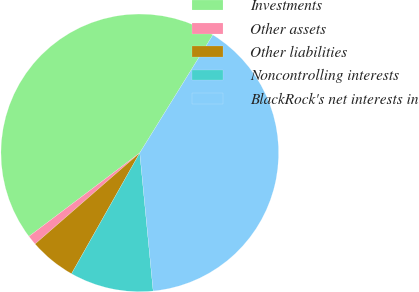<chart> <loc_0><loc_0><loc_500><loc_500><pie_chart><fcel>Investments<fcel>Other assets<fcel>Other liabilities<fcel>Noncontrolling interests<fcel>BlackRock's net interests in<nl><fcel>44.11%<fcel>1.12%<fcel>5.42%<fcel>9.72%<fcel>39.63%<nl></chart> 